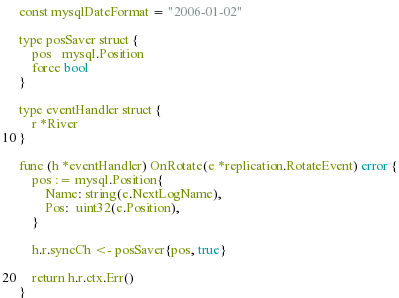<code> <loc_0><loc_0><loc_500><loc_500><_Go_>
const mysqlDateFormat = "2006-01-02"

type posSaver struct {
	pos   mysql.Position
	force bool
}

type eventHandler struct {
	r *River
}

func (h *eventHandler) OnRotate(e *replication.RotateEvent) error {
	pos := mysql.Position{
		Name: string(e.NextLogName),
		Pos:  uint32(e.Position),
	}

	h.r.syncCh <- posSaver{pos, true}

	return h.r.ctx.Err()
}
</code> 